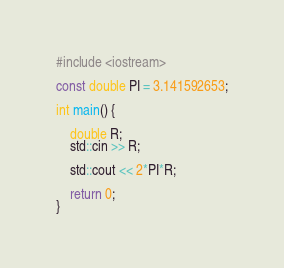<code> <loc_0><loc_0><loc_500><loc_500><_C++_>#include <iostream>

const double PI = 3.141592653;

int main() {

	double R;
	std::cin >> R;

	std::cout << 2*PI*R;

	return 0;
}
</code> 